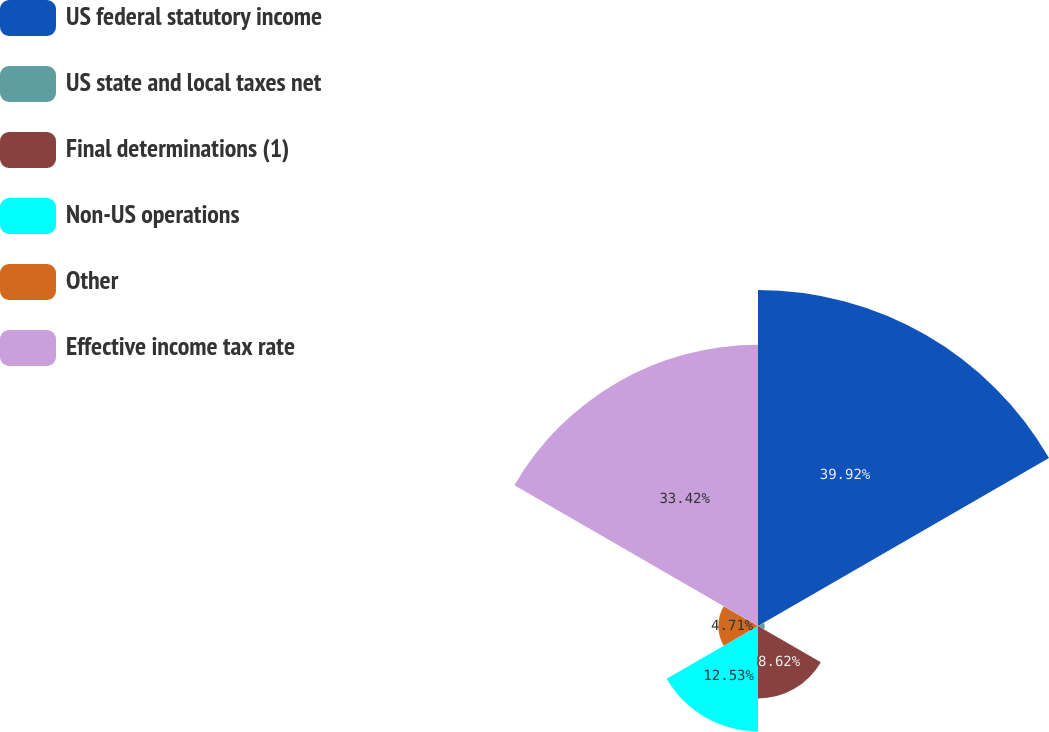Convert chart to OTSL. <chart><loc_0><loc_0><loc_500><loc_500><pie_chart><fcel>US federal statutory income<fcel>US state and local taxes net<fcel>Final determinations (1)<fcel>Non-US operations<fcel>Other<fcel>Effective income tax rate<nl><fcel>39.92%<fcel>0.8%<fcel>8.62%<fcel>12.53%<fcel>4.71%<fcel>33.42%<nl></chart> 